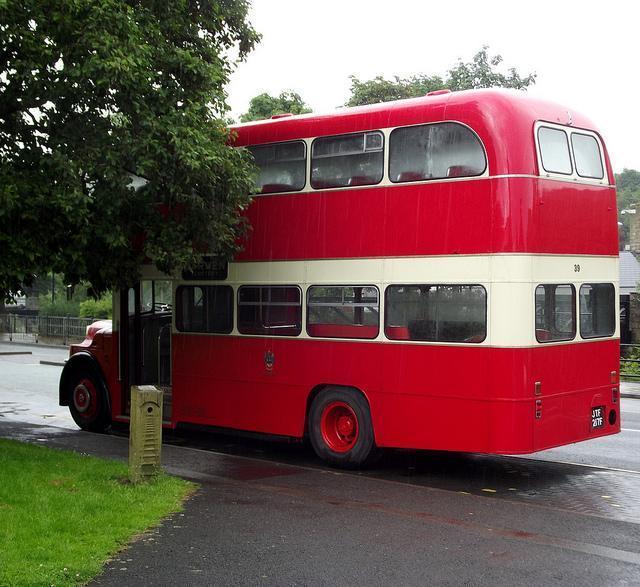How many decks is the bus?
Give a very brief answer. 2. 